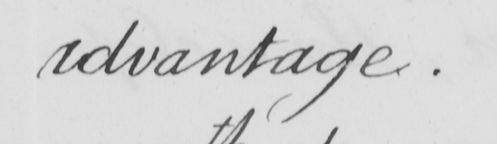What does this handwritten line say? advantage . 